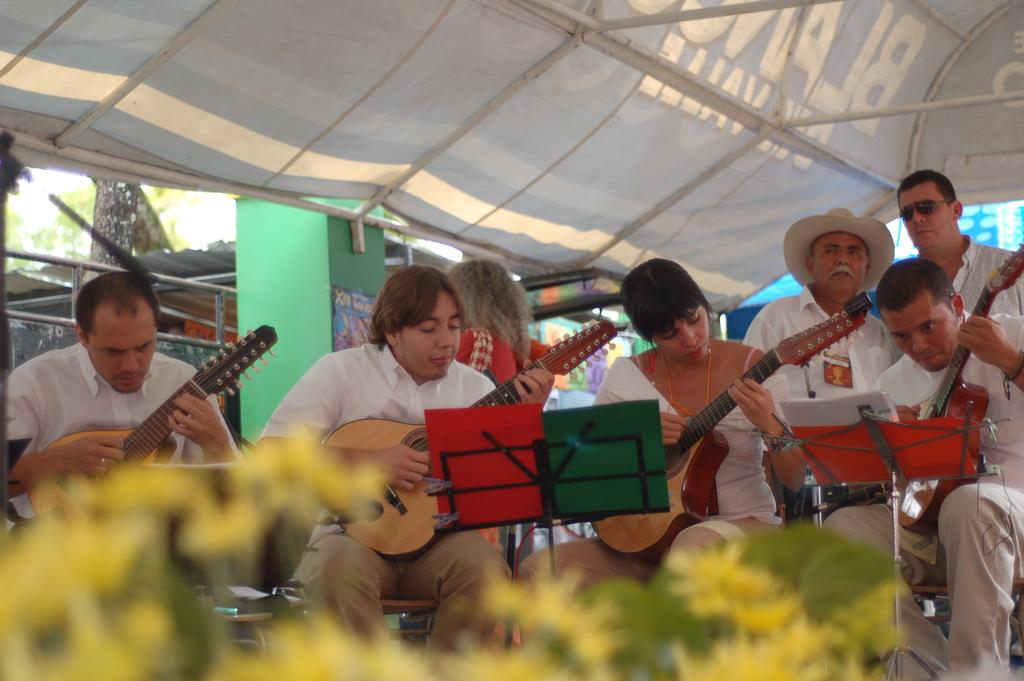What are the people in the image doing? The people in the image are playing guitars. How are the people positioned in the image? The people are sitting on chairs. What is above the group of people in the image? There is a tent above the group of people. Can you see a baby driving a car in the image? No, there is no baby driving a car in the image. 